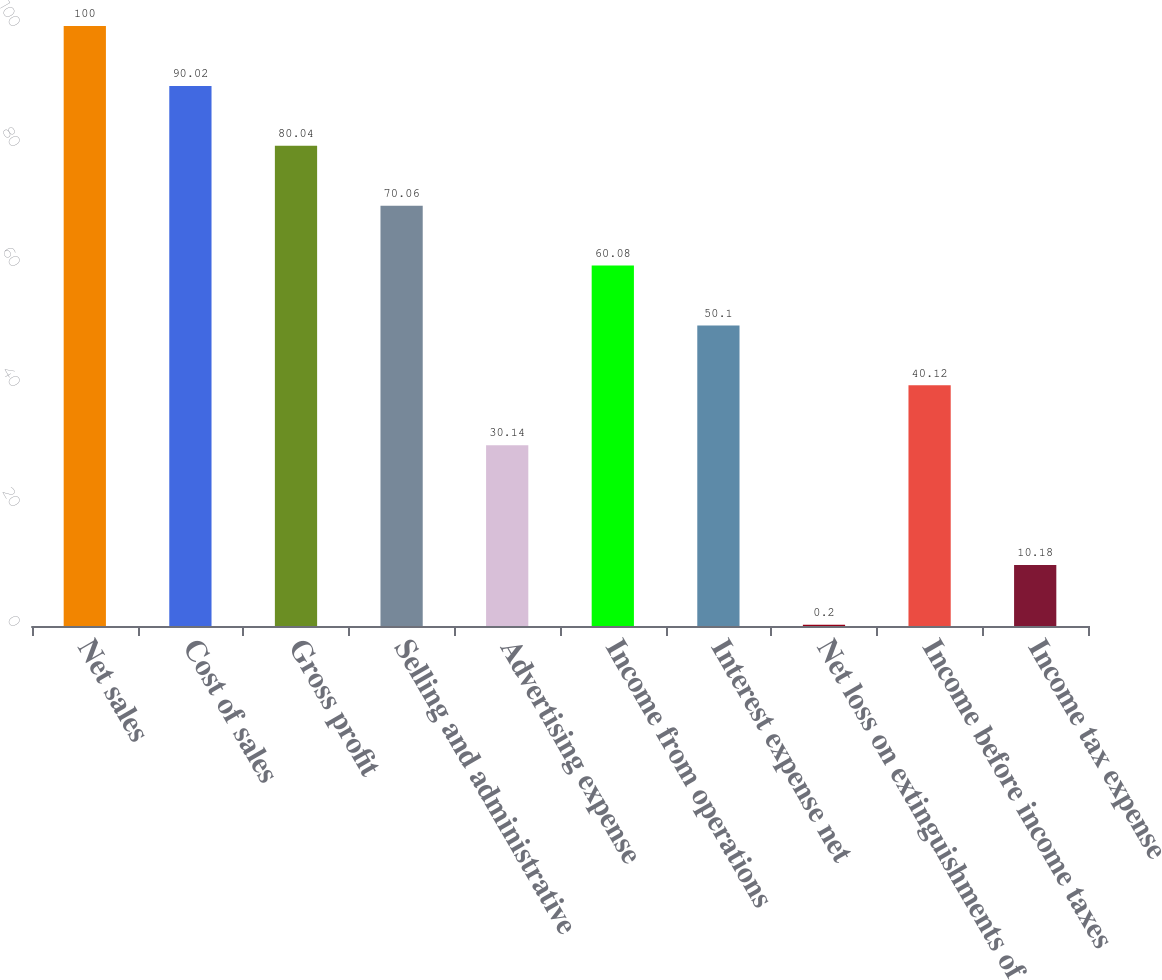Convert chart to OTSL. <chart><loc_0><loc_0><loc_500><loc_500><bar_chart><fcel>Net sales<fcel>Cost of sales<fcel>Gross profit<fcel>Selling and administrative<fcel>Advertising expense<fcel>Income from operations<fcel>Interest expense net<fcel>Net loss on extinguishments of<fcel>Income before income taxes<fcel>Income tax expense<nl><fcel>100<fcel>90.02<fcel>80.04<fcel>70.06<fcel>30.14<fcel>60.08<fcel>50.1<fcel>0.2<fcel>40.12<fcel>10.18<nl></chart> 